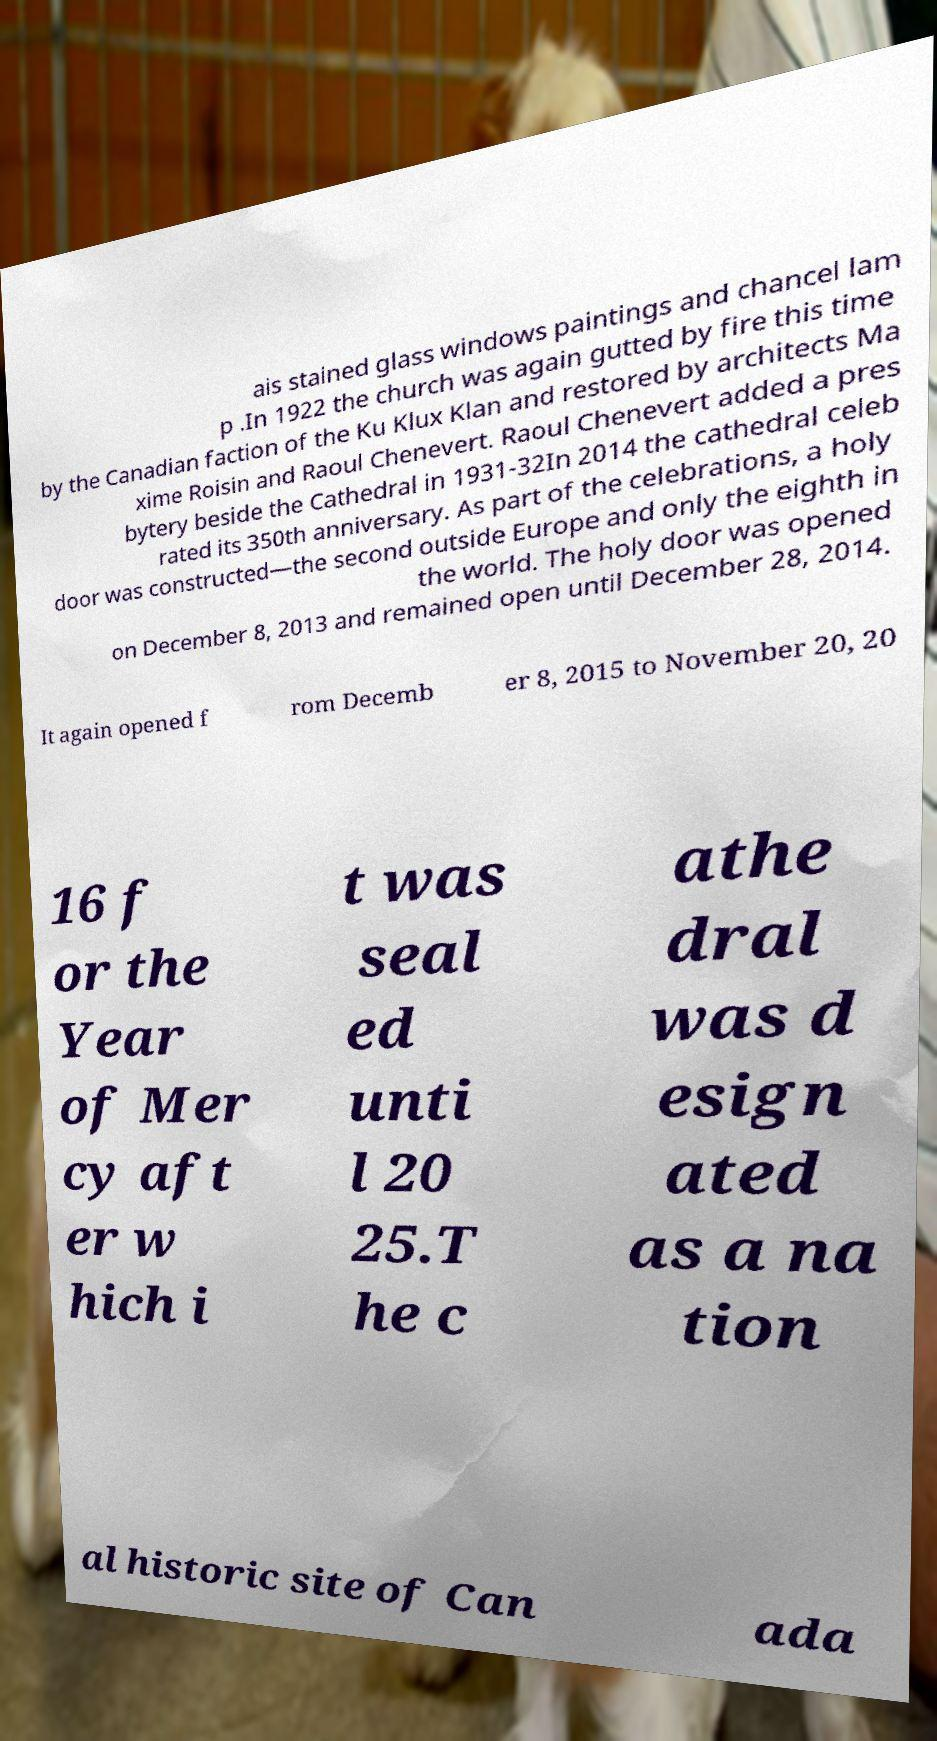Please read and relay the text visible in this image. What does it say? ais stained glass windows paintings and chancel lam p .In 1922 the church was again gutted by fire this time by the Canadian faction of the Ku Klux Klan and restored by architects Ma xime Roisin and Raoul Chenevert. Raoul Chenevert added a pres bytery beside the Cathedral in 1931-32In 2014 the cathedral celeb rated its 350th anniversary. As part of the celebrations, a holy door was constructed—the second outside Europe and only the eighth in the world. The holy door was opened on December 8, 2013 and remained open until December 28, 2014. It again opened f rom Decemb er 8, 2015 to November 20, 20 16 f or the Year of Mer cy aft er w hich i t was seal ed unti l 20 25.T he c athe dral was d esign ated as a na tion al historic site of Can ada 